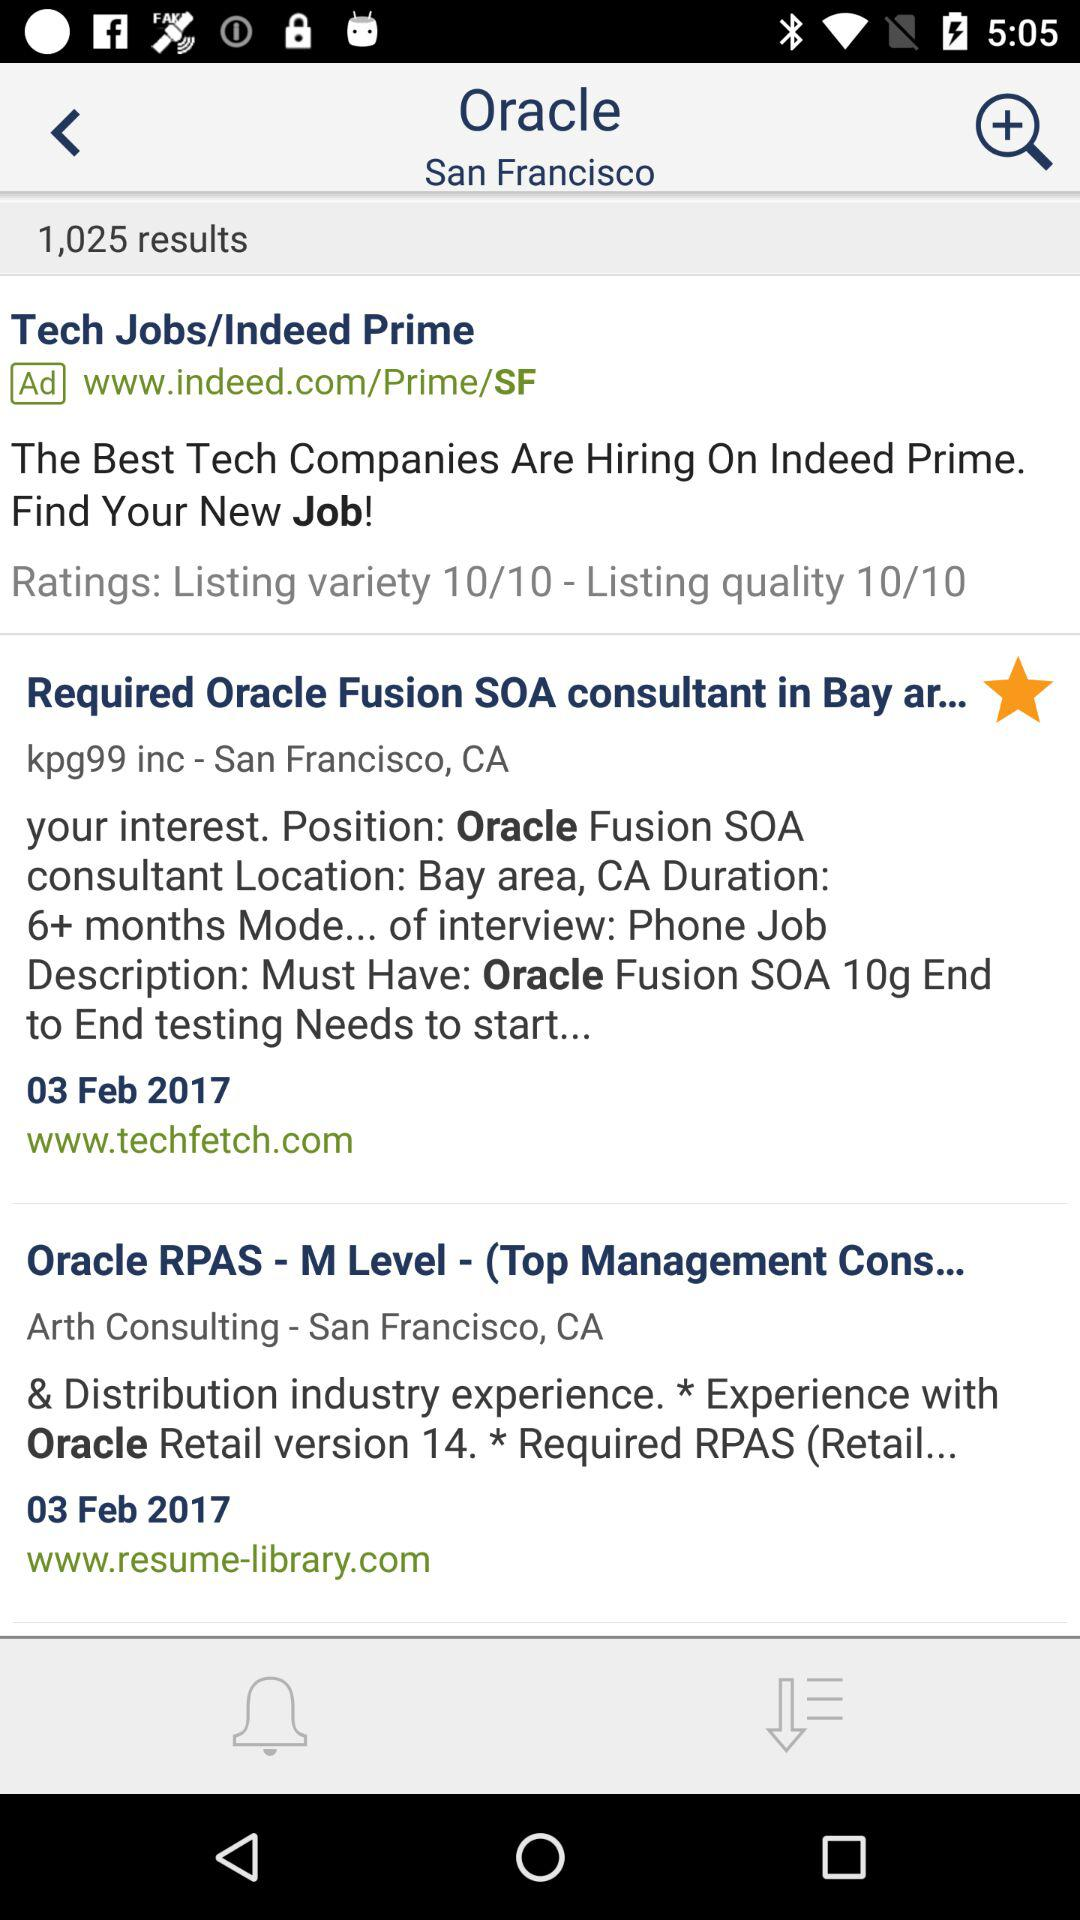How many results are there? There are 1,025 results. 